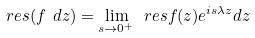Convert formula to latex. <formula><loc_0><loc_0><loc_500><loc_500>\ r e s ( f \ d z ) = \lim _ { s \to 0 ^ { + } } \ r e s { f ( z ) e ^ { i s \lambda z } d z }</formula> 